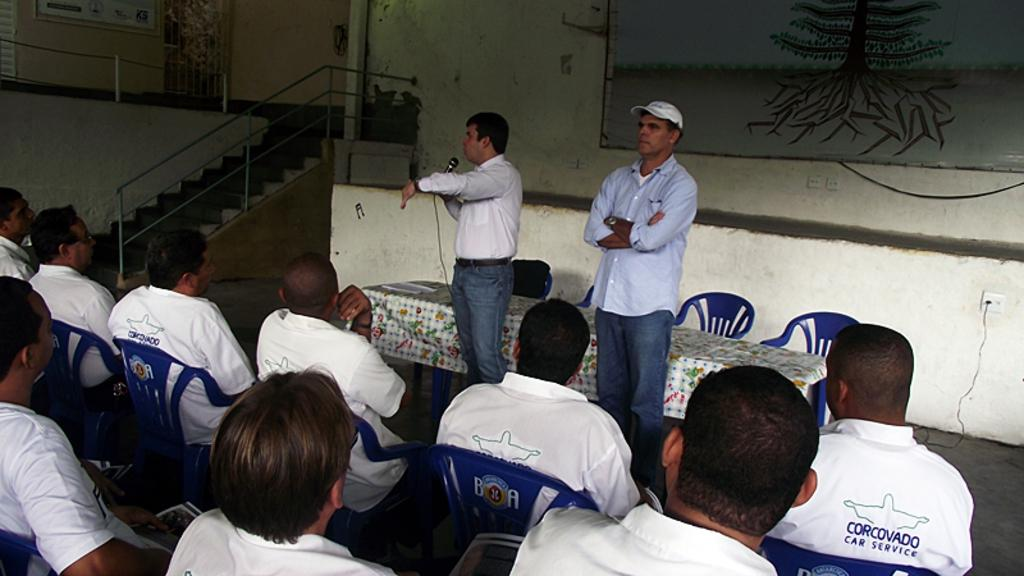<image>
Write a terse but informative summary of the picture. Two men speak too a gathering of male employees in shirts from Corovado Car Service 